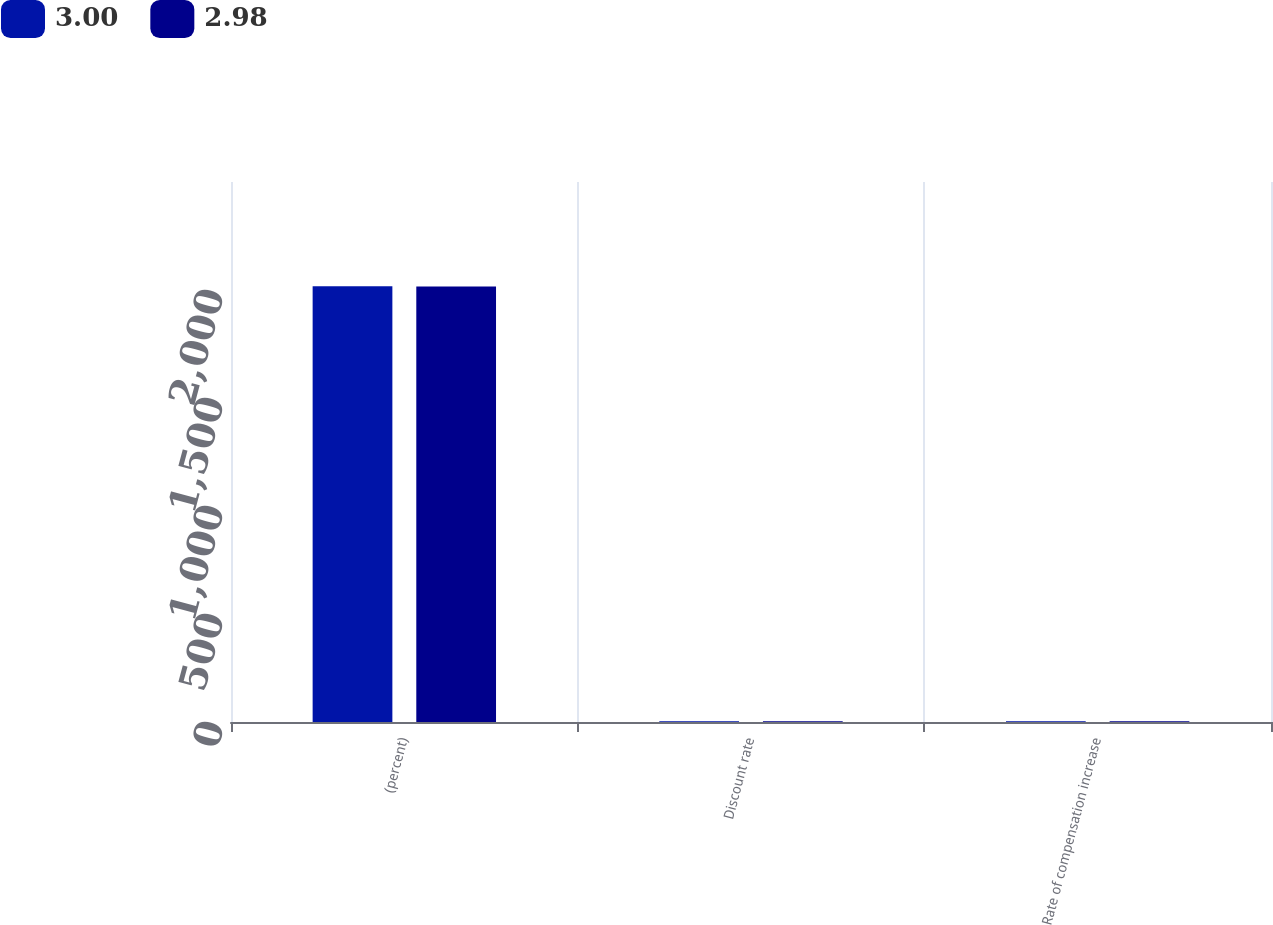Convert chart. <chart><loc_0><loc_0><loc_500><loc_500><stacked_bar_chart><ecel><fcel>(percent)<fcel>Discount rate<fcel>Rate of compensation increase<nl><fcel>3<fcel>2017<fcel>3.55<fcel>2.98<nl><fcel>2.98<fcel>2016<fcel>3.94<fcel>3<nl></chart> 